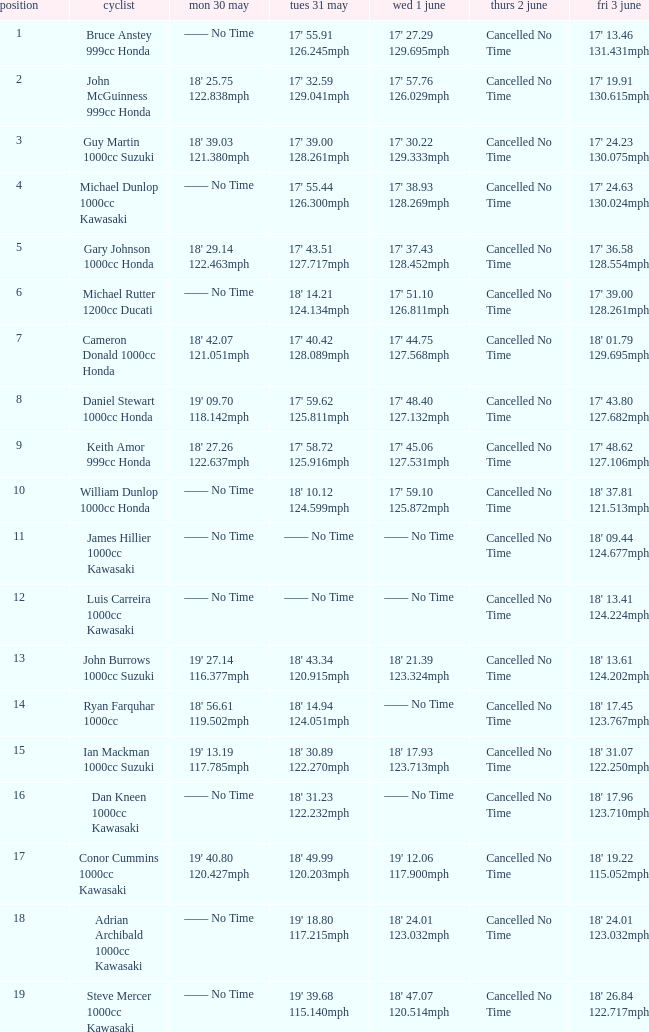What is the Fri 3 June time for the rider whose Tues 31 May time was 19' 18.80 117.215mph? 18' 24.01 123.032mph. 